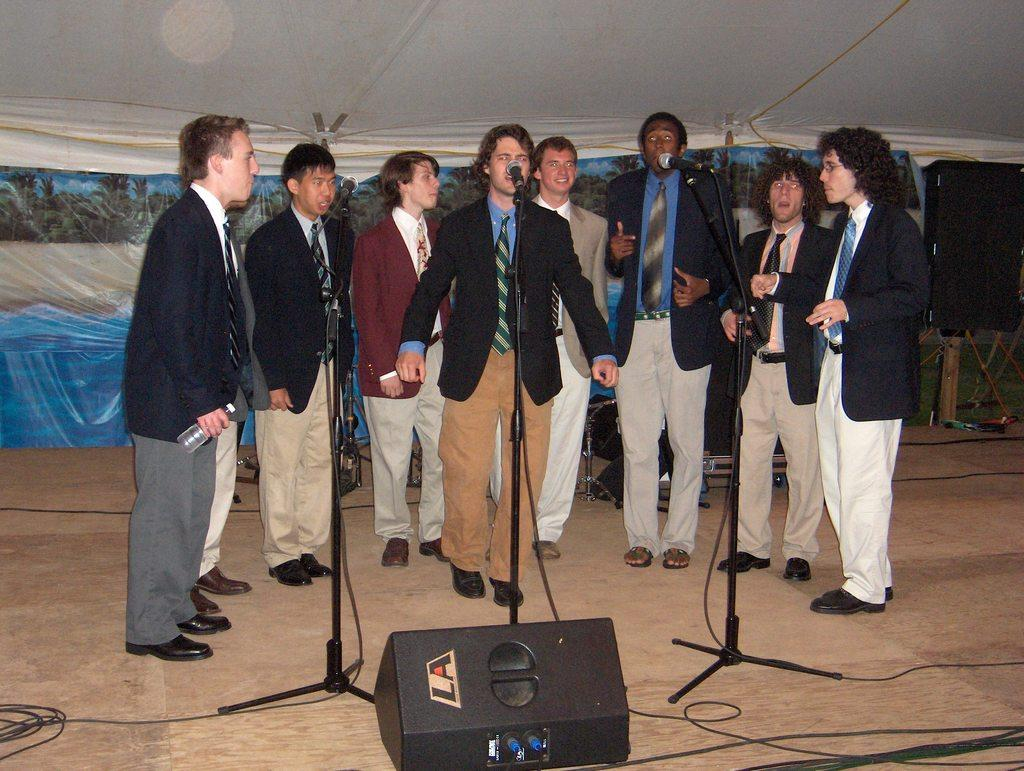What are the men in the image wearing? The men in the image are wearing suits. Where are the men standing in the image? The men are standing on a stage. What are the men doing on the stage? The men are singing into microphones. What can be seen behind the men on the stage? There are music instruments behind the men. What is above the stage in the image? There is a tent above the stage. How much sugar is being used by the horses in the image? There are no horses present in the image, so the amount of sugar being used cannot be determined. What design elements can be seen on the men's suits in the image? The provided facts do not mention any specific design elements on the men's suits, so we cannot answer this question based on the information given. 